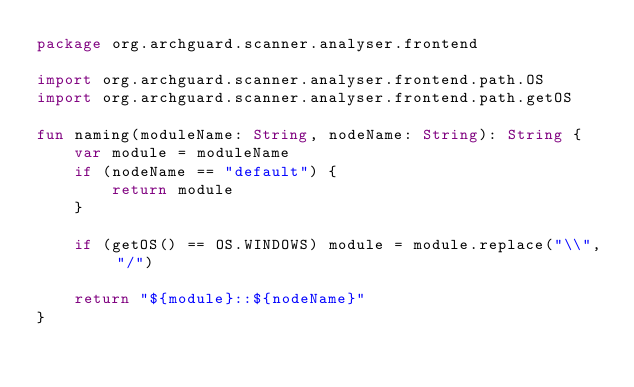Convert code to text. <code><loc_0><loc_0><loc_500><loc_500><_Kotlin_>package org.archguard.scanner.analyser.frontend

import org.archguard.scanner.analyser.frontend.path.OS
import org.archguard.scanner.analyser.frontend.path.getOS

fun naming(moduleName: String, nodeName: String): String {
    var module = moduleName
    if (nodeName == "default") {
        return module
    }

    if (getOS() == OS.WINDOWS) module = module.replace("\\", "/")

    return "${module}::${nodeName}"
}

</code> 